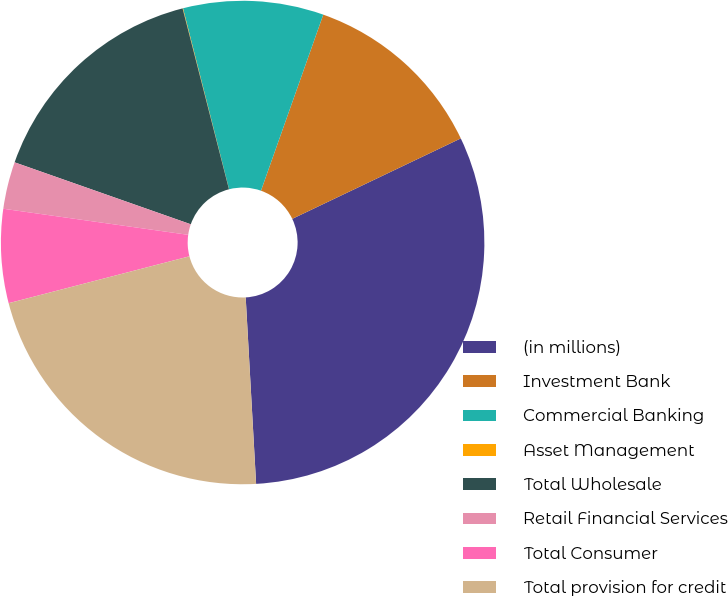Convert chart to OTSL. <chart><loc_0><loc_0><loc_500><loc_500><pie_chart><fcel>(in millions)<fcel>Investment Bank<fcel>Commercial Banking<fcel>Asset Management<fcel>Total Wholesale<fcel>Retail Financial Services<fcel>Total Consumer<fcel>Total provision for credit<nl><fcel>31.2%<fcel>12.5%<fcel>9.38%<fcel>0.03%<fcel>15.62%<fcel>3.15%<fcel>6.27%<fcel>21.85%<nl></chart> 